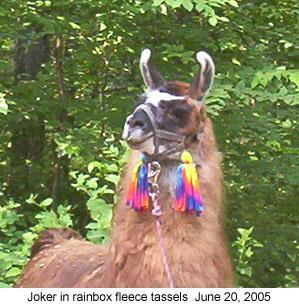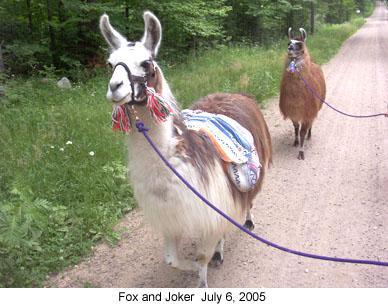The first image is the image on the left, the second image is the image on the right. Given the left and right images, does the statement "Each image includes one foreground llama wearing a pair of colorful tassles somewhere on its head." hold true? Answer yes or no. Yes. The first image is the image on the left, the second image is the image on the right. Evaluate the accuracy of this statement regarding the images: "Red material hangs from the ears of the animal in the image on the left.". Is it true? Answer yes or no. No. 